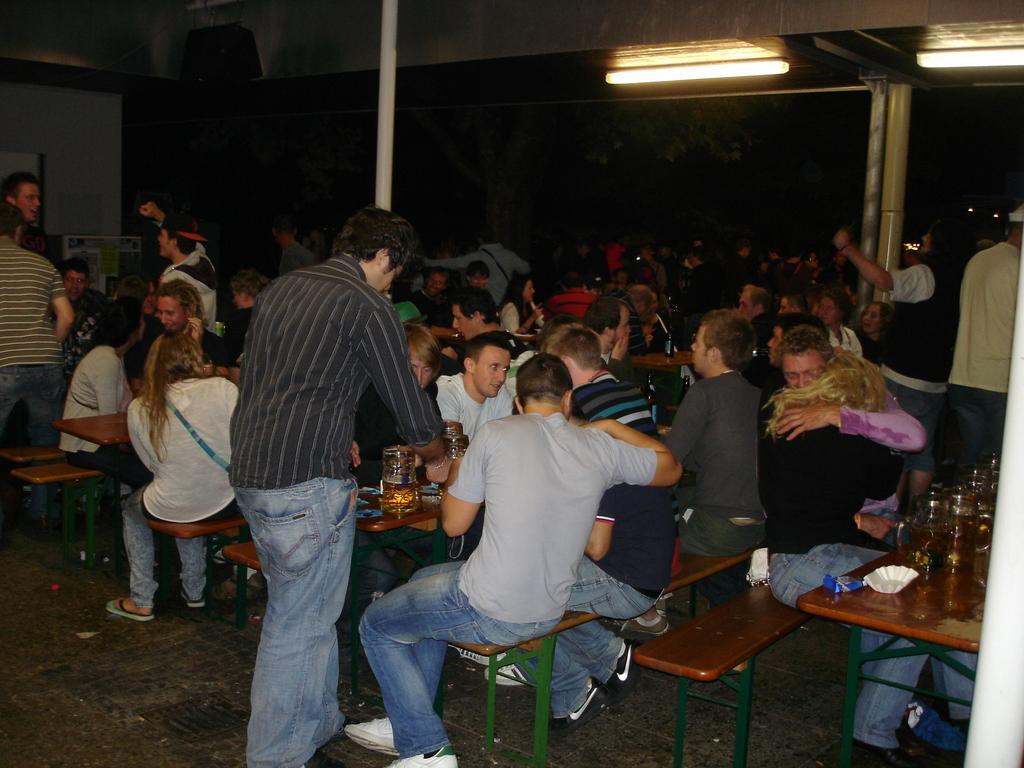Please provide a concise description of this image. in this image we have a group of people standing and sitting in the chairs ,another group of people standing and sitting in the chairs and in the table we have glass full of beers and light fixed to the wall. 